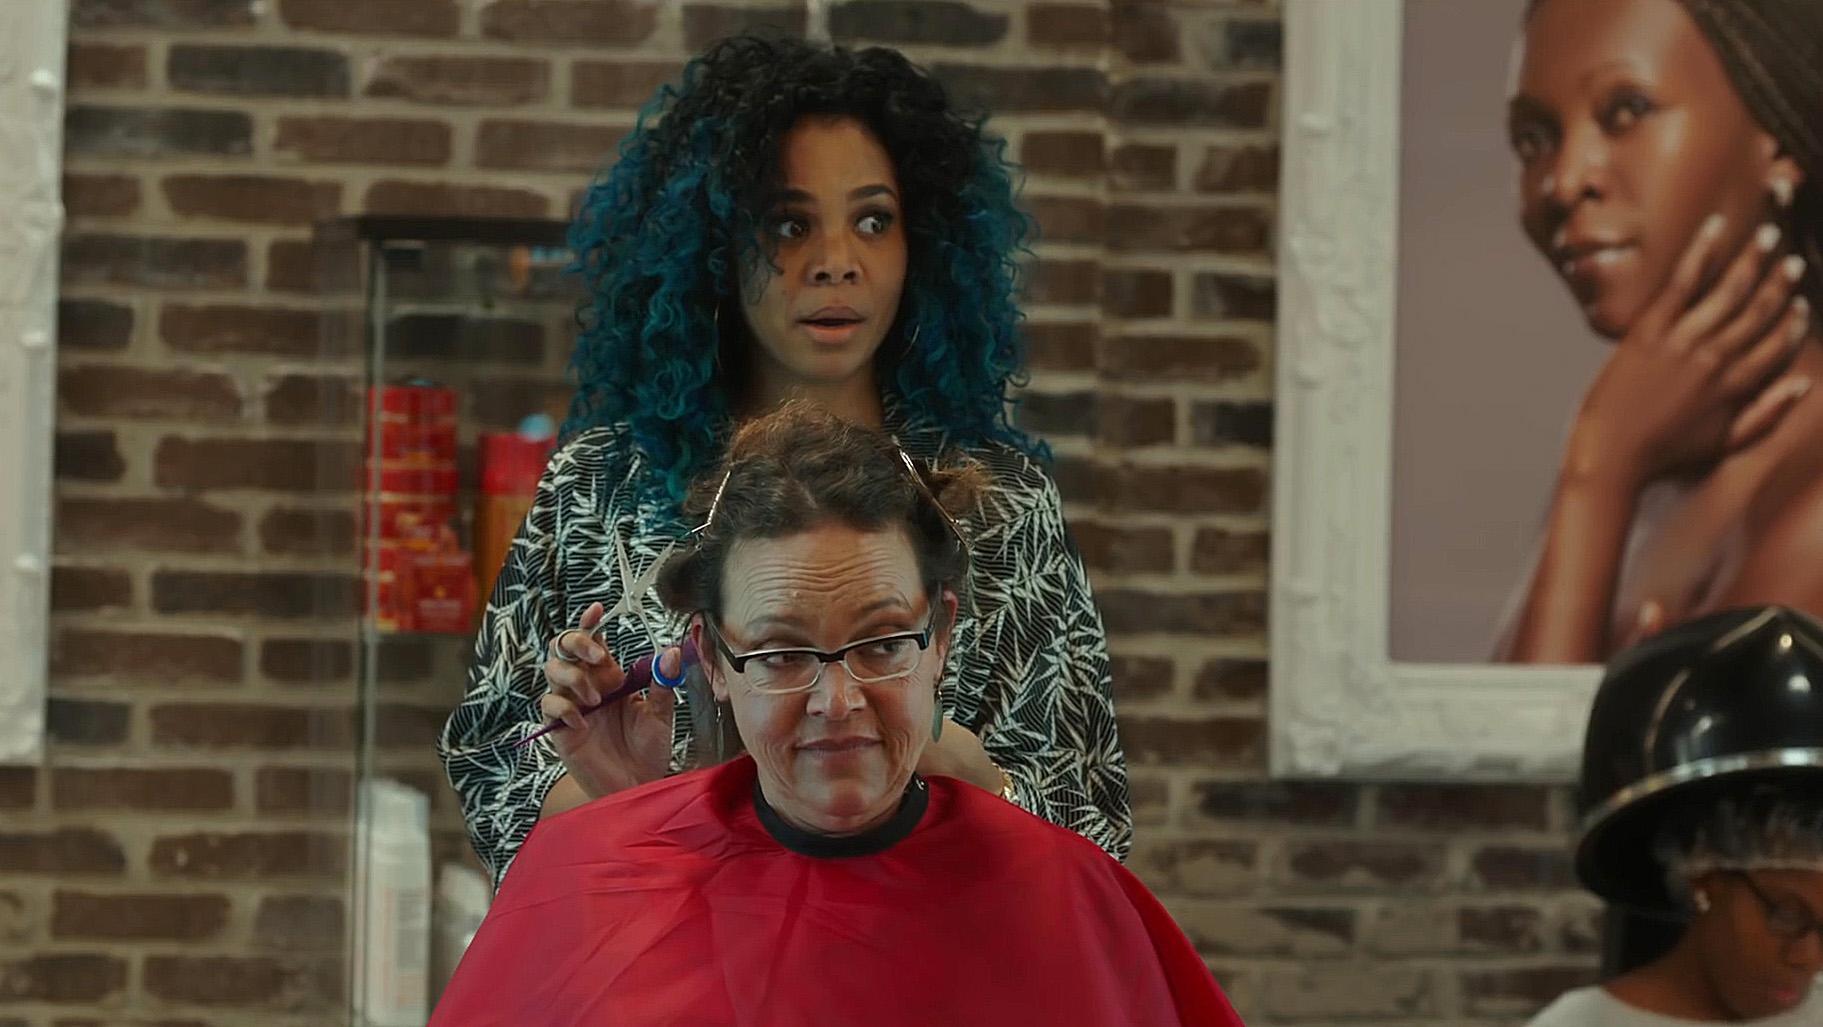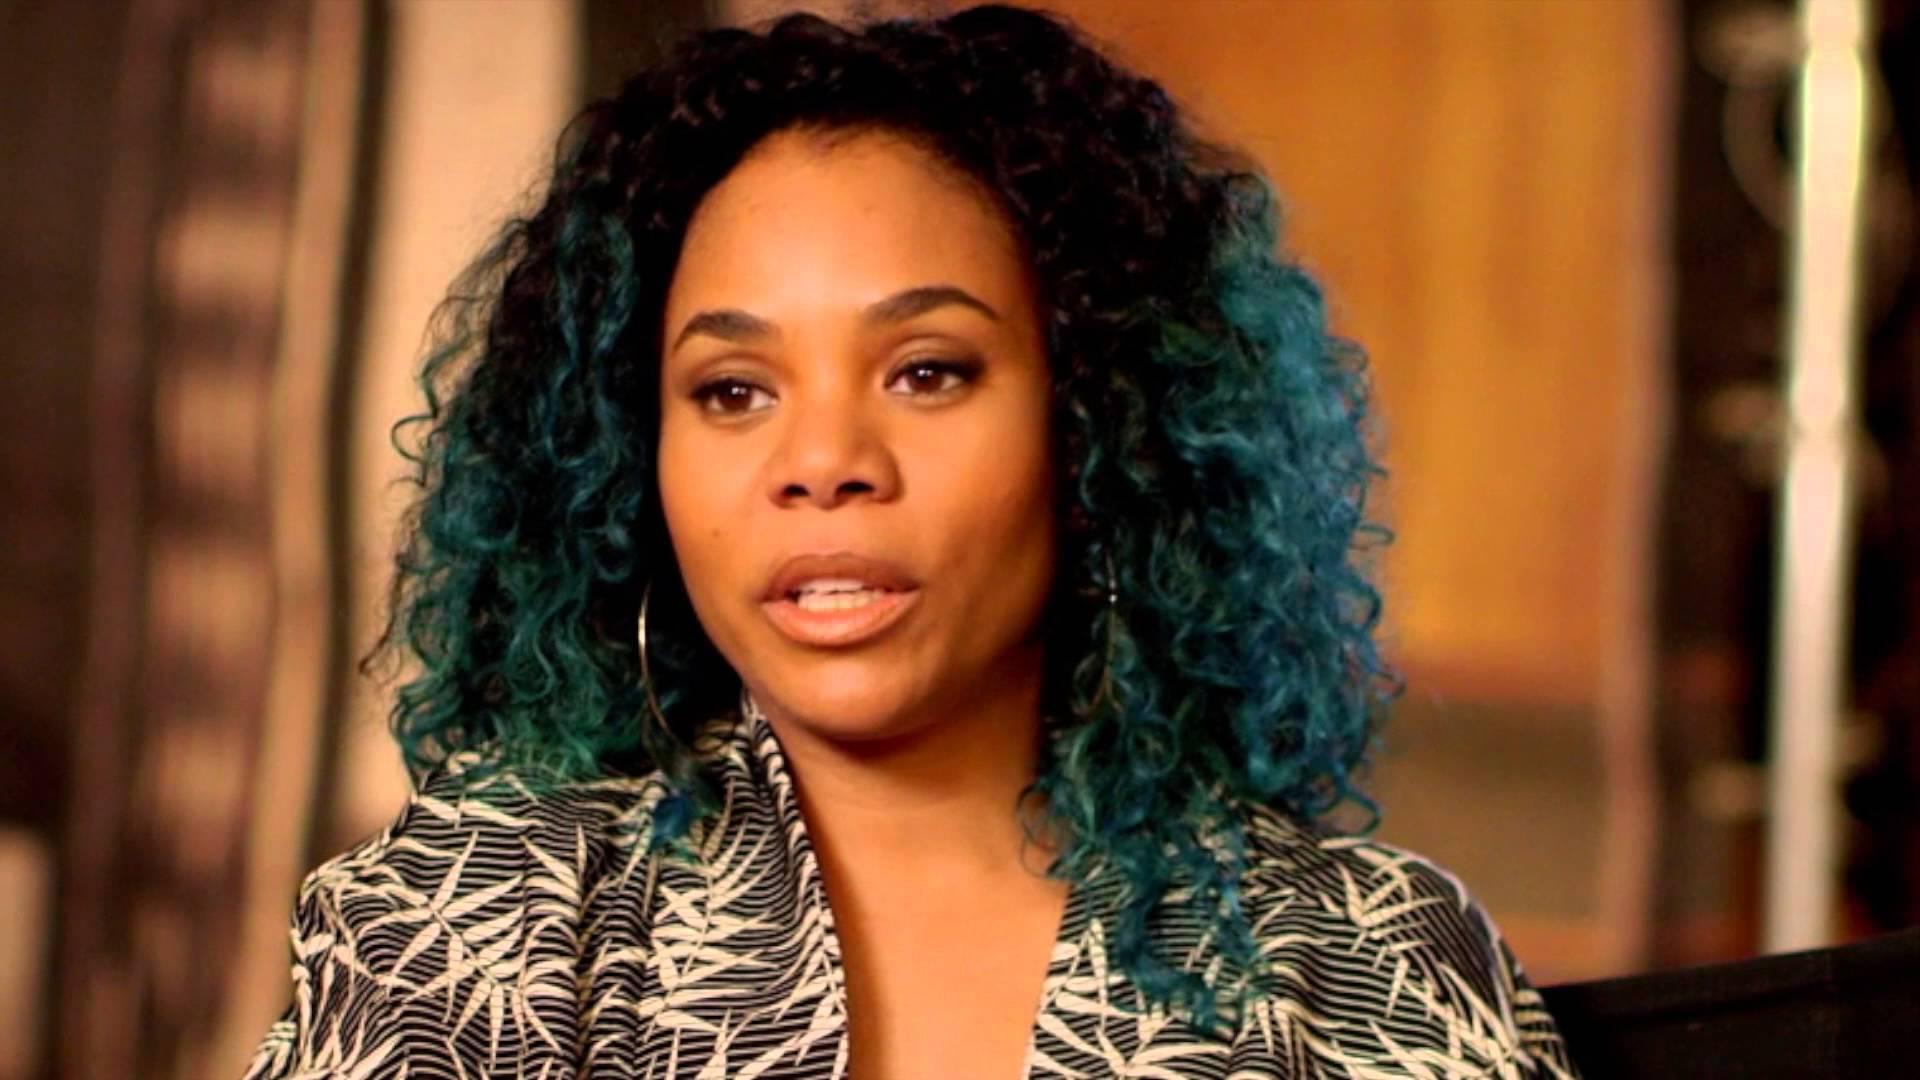The first image is the image on the left, the second image is the image on the right. Given the left and right images, does the statement "None of the women in the pictures have blue hair." hold true? Answer yes or no. No. The first image is the image on the left, the second image is the image on the right. Examine the images to the left and right. Is the description "An image shows a woman in a printed top standing behind a customer in a red smock." accurate? Answer yes or no. Yes. 